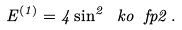<formula> <loc_0><loc_0><loc_500><loc_500>E ^ { ( 1 ) } = 4 \sin ^ { 2 } \ k o { \ f { p } { 2 } } \, .</formula> 